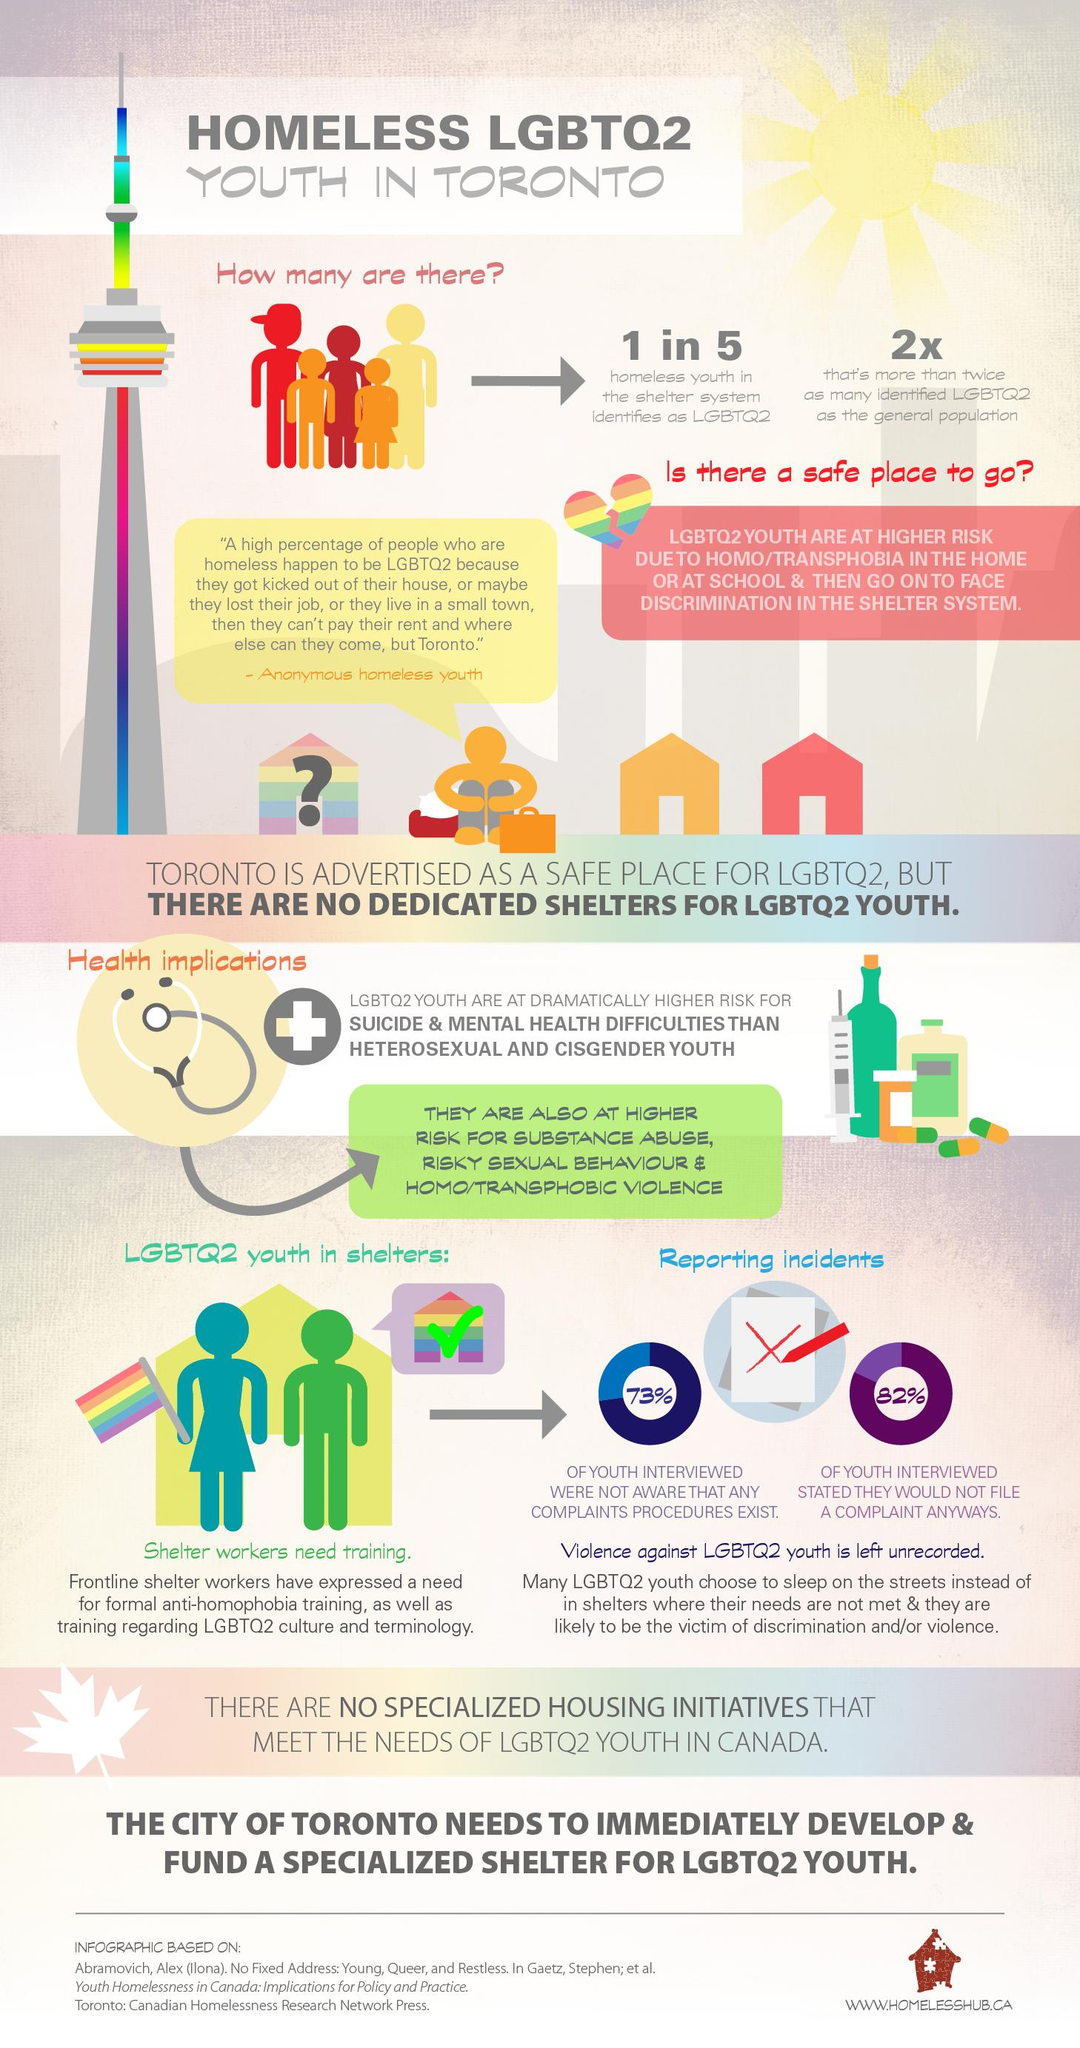Give some essential details in this illustration. According to a recent study, only 18% of youth in shelters are ready to file a complaint. 